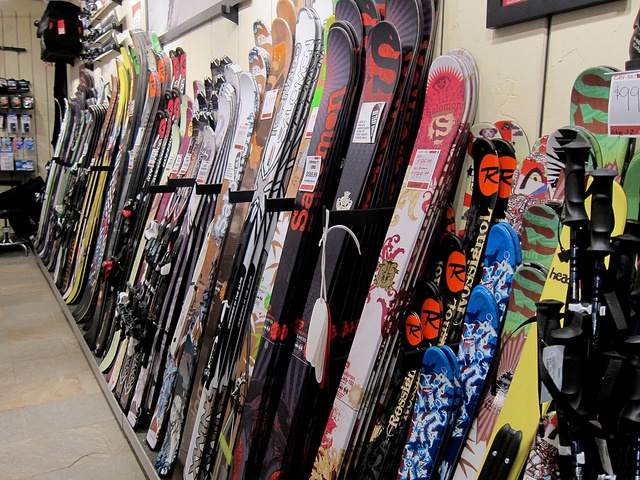Describe the objects in this image and their specific colors. I can see skis in darkgray, black, and brown tones, skis in darkgray, black, gray, and maroon tones, skis in darkgray, black, gray, brown, and lightgray tones, snowboard in darkgray, black, lightgray, and gray tones, and snowboard in darkgray, black, gray, and lightgray tones in this image. 